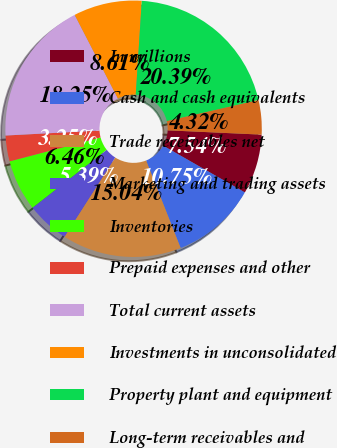<chart> <loc_0><loc_0><loc_500><loc_500><pie_chart><fcel>In millions<fcel>Cash and cash equivalents<fcel>Trade receivables net<fcel>Marketing and trading assets<fcel>Inventories<fcel>Prepaid expenses and other<fcel>Total current assets<fcel>Investments in unconsolidated<fcel>Property plant and equipment<fcel>Long-term receivables and<nl><fcel>7.54%<fcel>10.75%<fcel>15.04%<fcel>5.39%<fcel>6.46%<fcel>3.25%<fcel>18.25%<fcel>8.61%<fcel>20.39%<fcel>4.32%<nl></chart> 